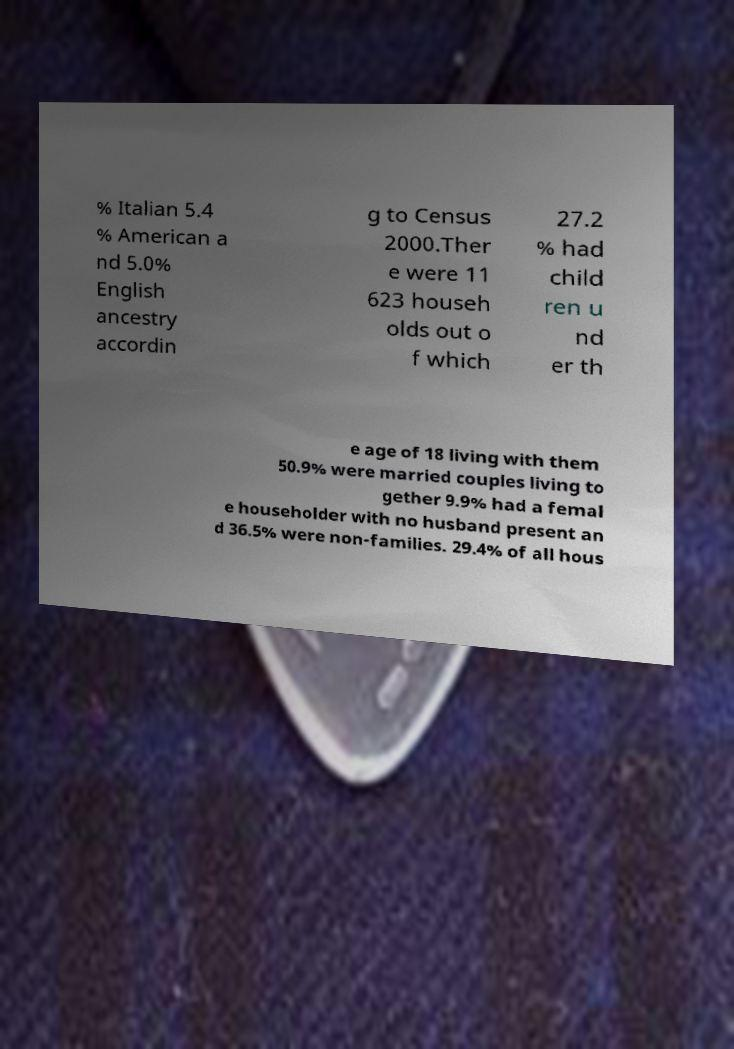Could you extract and type out the text from this image? % Italian 5.4 % American a nd 5.0% English ancestry accordin g to Census 2000.Ther e were 11 623 househ olds out o f which 27.2 % had child ren u nd er th e age of 18 living with them 50.9% were married couples living to gether 9.9% had a femal e householder with no husband present an d 36.5% were non-families. 29.4% of all hous 